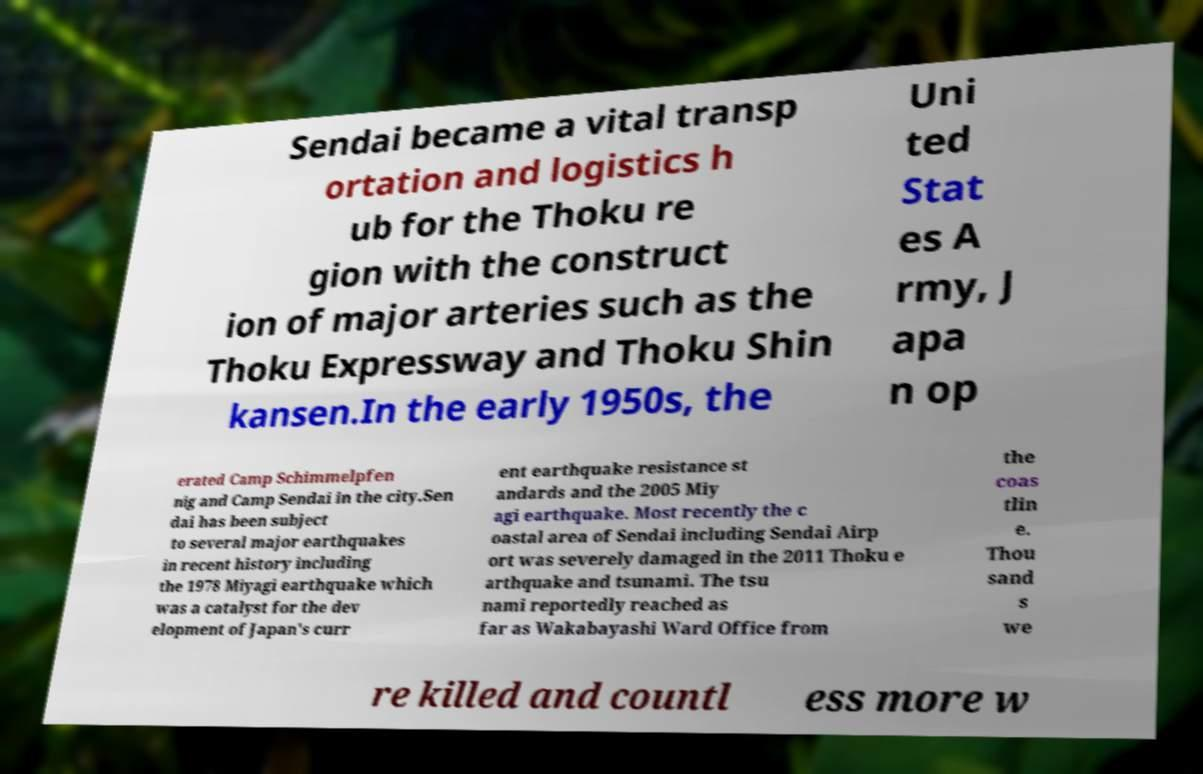What messages or text are displayed in this image? I need them in a readable, typed format. Sendai became a vital transp ortation and logistics h ub for the Thoku re gion with the construct ion of major arteries such as the Thoku Expressway and Thoku Shin kansen.In the early 1950s, the Uni ted Stat es A rmy, J apa n op erated Camp Schimmelpfen nig and Camp Sendai in the city.Sen dai has been subject to several major earthquakes in recent history including the 1978 Miyagi earthquake which was a catalyst for the dev elopment of Japan's curr ent earthquake resistance st andards and the 2005 Miy agi earthquake. Most recently the c oastal area of Sendai including Sendai Airp ort was severely damaged in the 2011 Thoku e arthquake and tsunami. The tsu nami reportedly reached as far as Wakabayashi Ward Office from the coas tlin e. Thou sand s we re killed and countl ess more w 